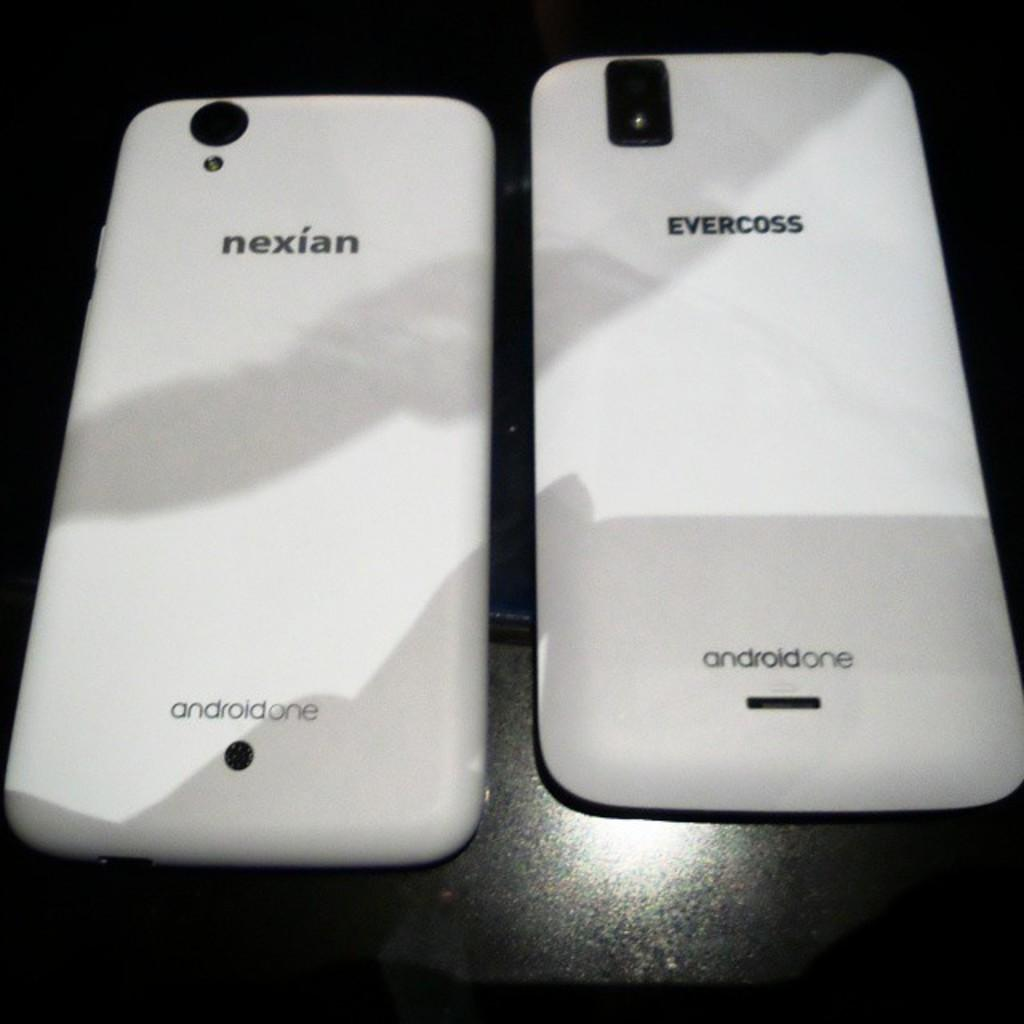<image>
Summarize the visual content of the image. Two white Nexian and evercoss android cellphones on a table 